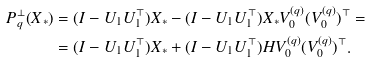Convert formula to latex. <formula><loc_0><loc_0><loc_500><loc_500>P _ { q } ^ { \perp } ( X _ { * } ) & = ( I - U _ { 1 } U ^ { \top } _ { 1 } ) X _ { * } - ( I - U _ { 1 } U ^ { \top } _ { 1 } ) X _ { * } V ^ { ( q ) } _ { 0 } ( V ^ { ( q ) } _ { 0 } ) ^ { \top } = \\ & = ( I - U _ { 1 } U ^ { \top } _ { 1 } ) X _ { * } + ( I - U _ { 1 } U ^ { \top } _ { 1 } ) H V ^ { ( q ) } _ { 0 } ( V ^ { ( q ) } _ { 0 } ) ^ { \top } .</formula> 